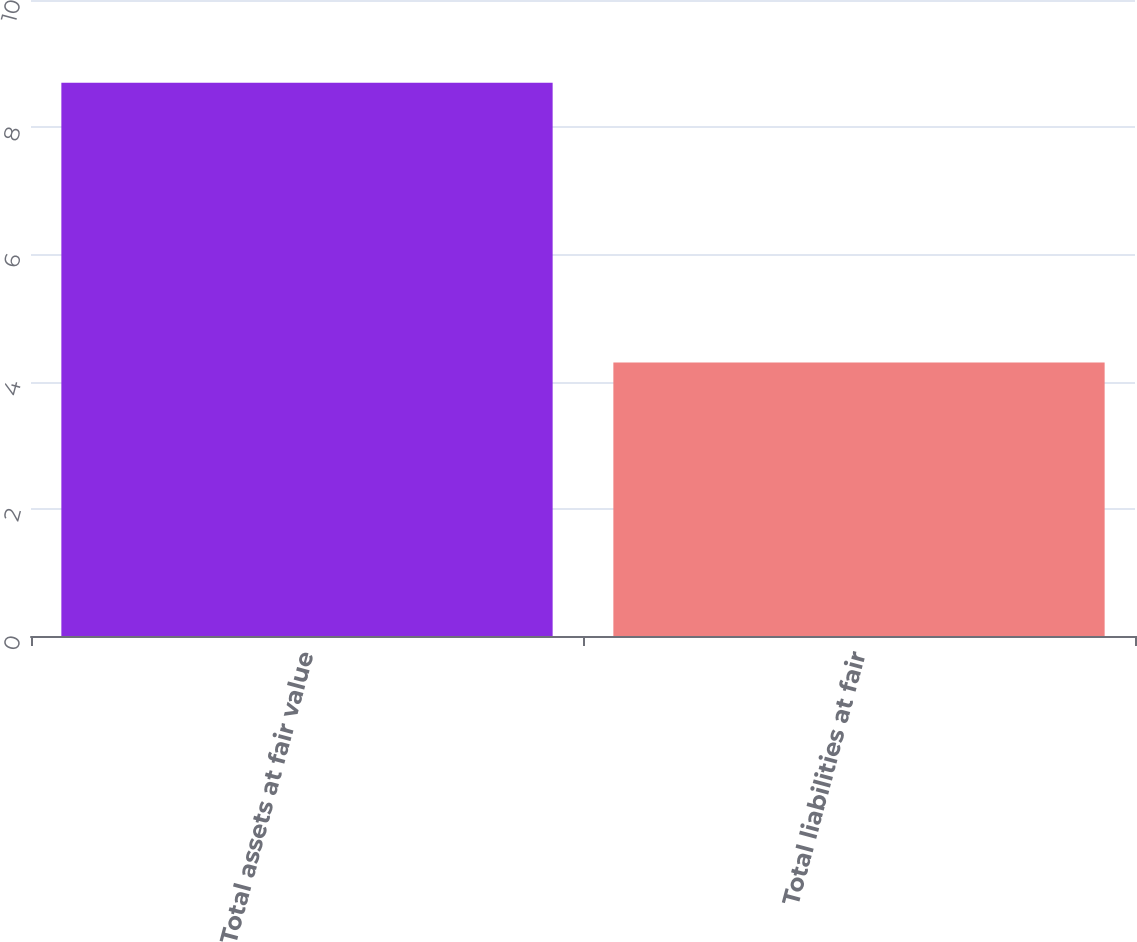<chart> <loc_0><loc_0><loc_500><loc_500><bar_chart><fcel>Total assets at fair value<fcel>Total liabilities at fair<nl><fcel>8.7<fcel>4.3<nl></chart> 